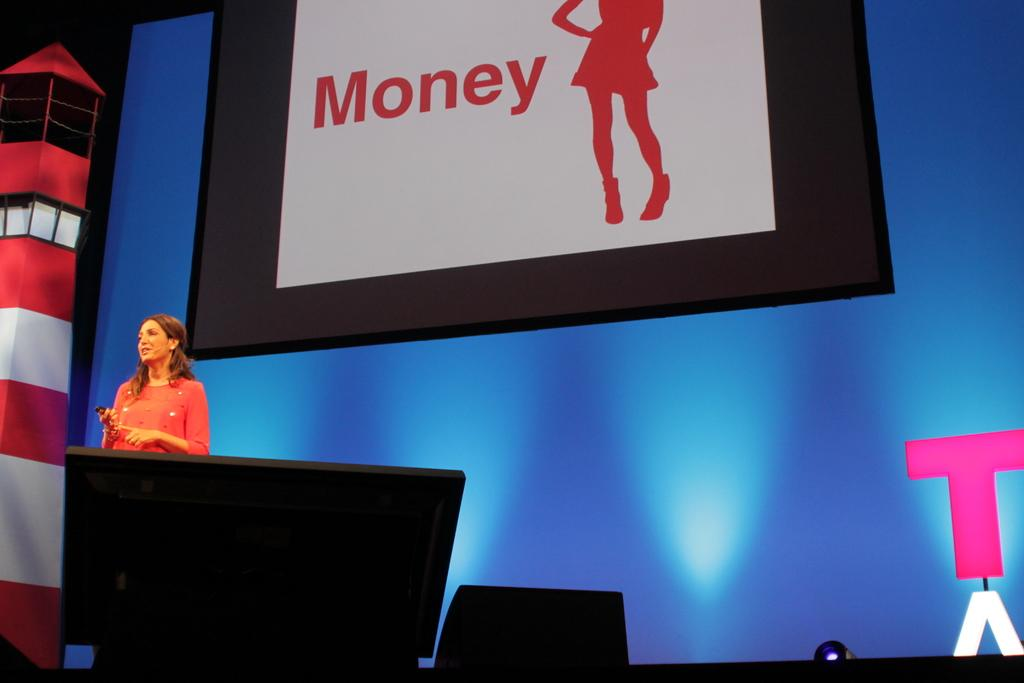<image>
Summarize the visual content of the image. a sign with the word money on it 